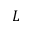<formula> <loc_0><loc_0><loc_500><loc_500>L</formula> 